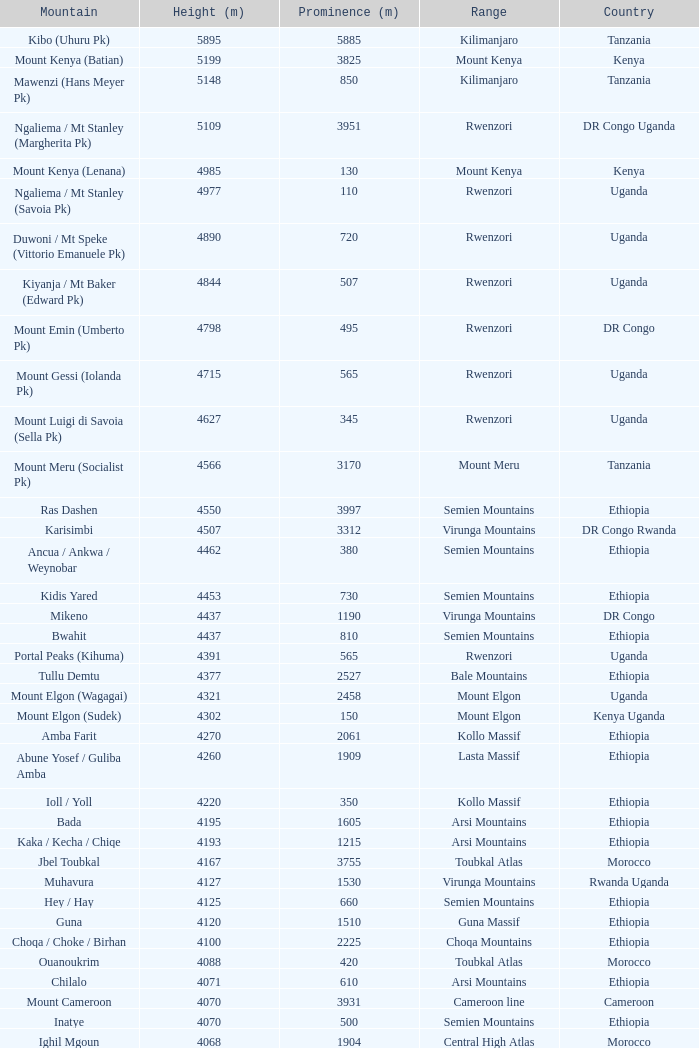Which Country has a Height (m) larger than 4100, and a Range of arsi mountains, and a Mountain of bada? Ethiopia. 